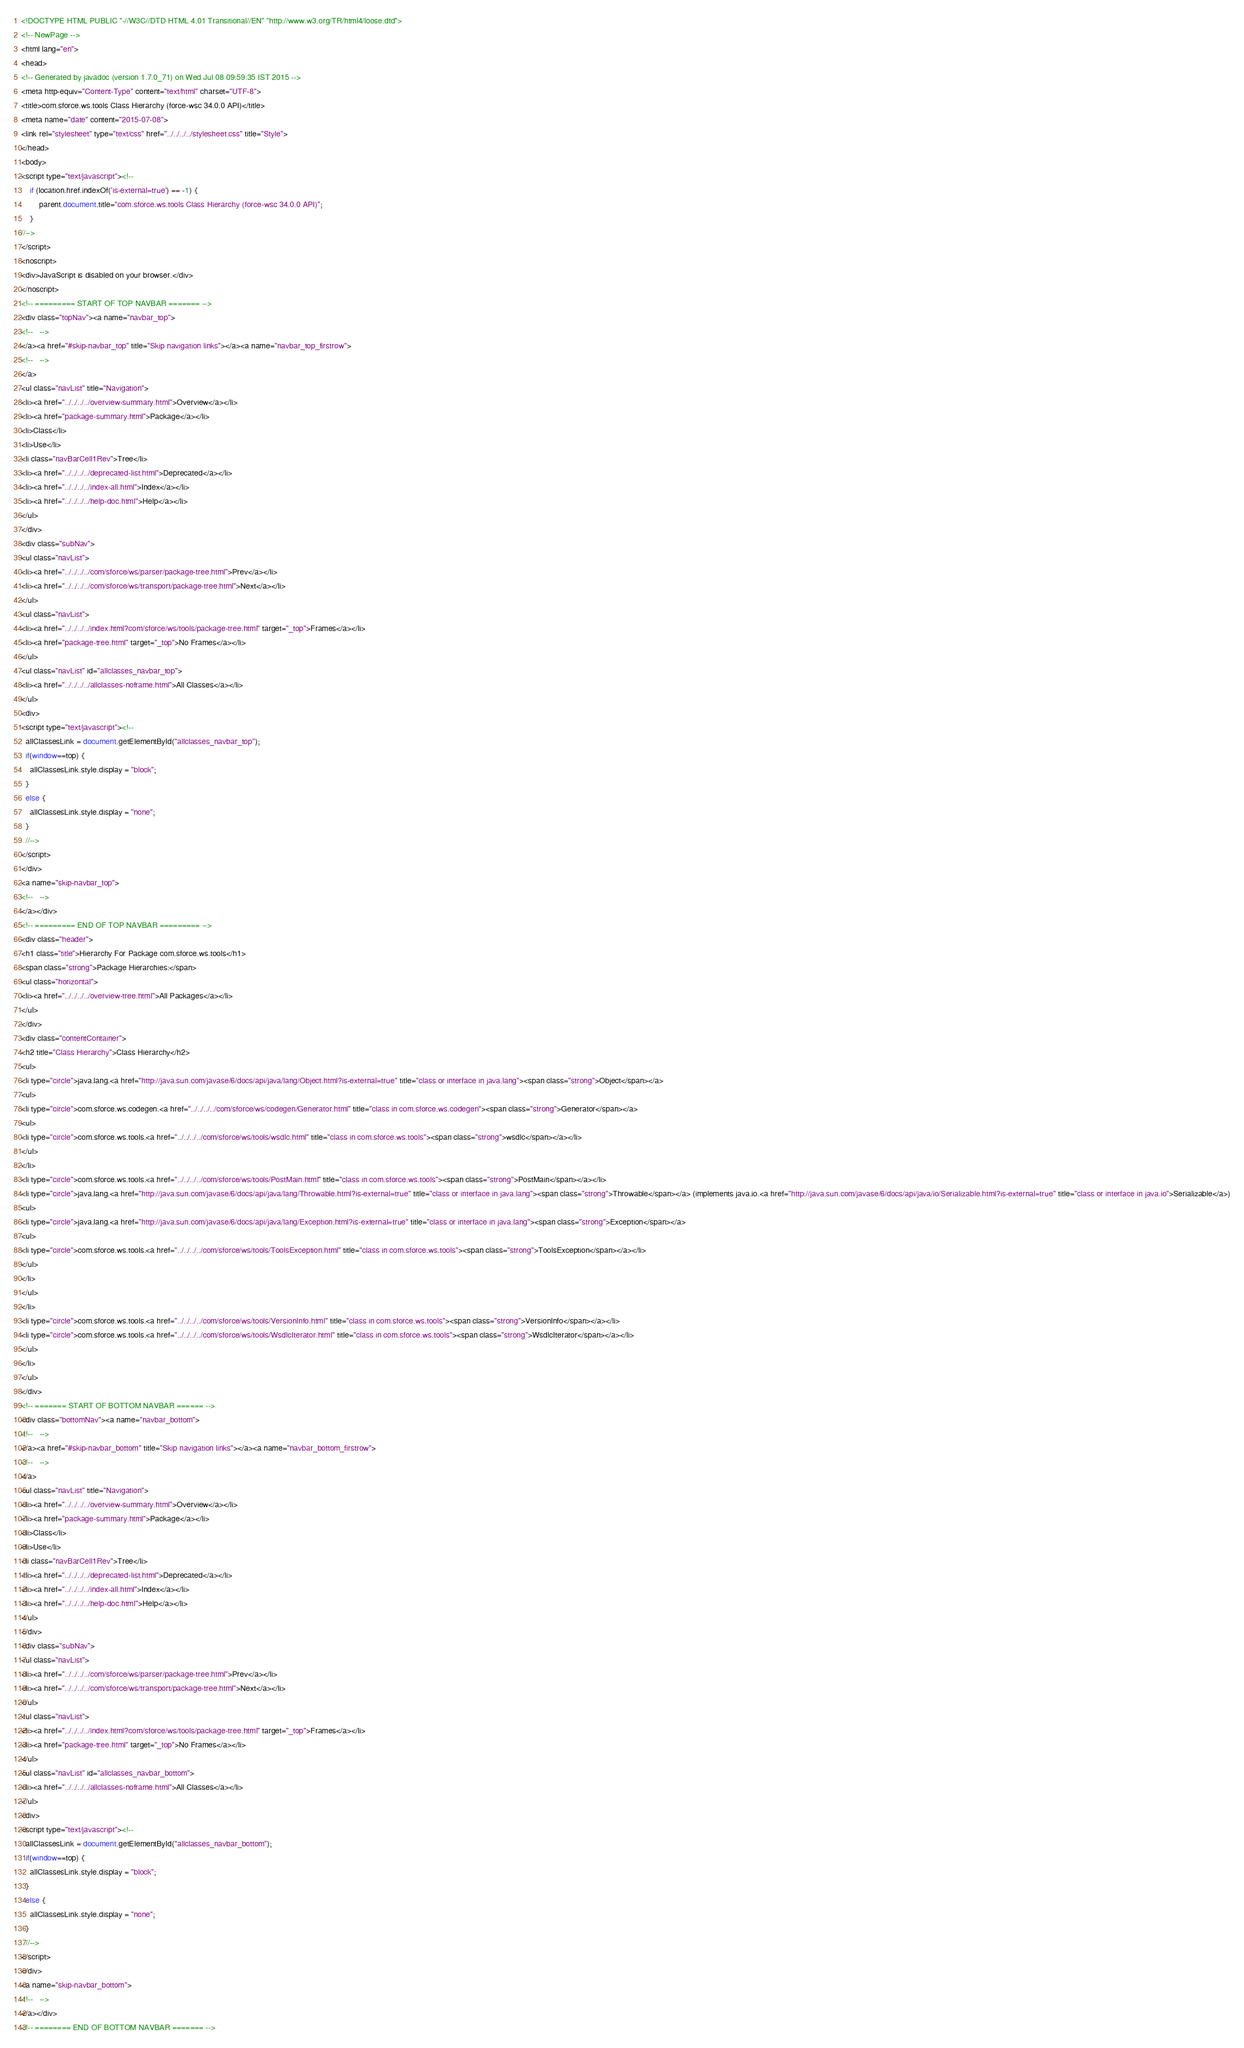<code> <loc_0><loc_0><loc_500><loc_500><_HTML_><!DOCTYPE HTML PUBLIC "-//W3C//DTD HTML 4.01 Transitional//EN" "http://www.w3.org/TR/html4/loose.dtd">
<!-- NewPage -->
<html lang="en">
<head>
<!-- Generated by javadoc (version 1.7.0_71) on Wed Jul 08 09:59:35 IST 2015 -->
<meta http-equiv="Content-Type" content="text/html" charset="UTF-8">
<title>com.sforce.ws.tools Class Hierarchy (force-wsc 34.0.0 API)</title>
<meta name="date" content="2015-07-08">
<link rel="stylesheet" type="text/css" href="../../../../stylesheet.css" title="Style">
</head>
<body>
<script type="text/javascript"><!--
    if (location.href.indexOf('is-external=true') == -1) {
        parent.document.title="com.sforce.ws.tools Class Hierarchy (force-wsc 34.0.0 API)";
    }
//-->
</script>
<noscript>
<div>JavaScript is disabled on your browser.</div>
</noscript>
<!-- ========= START OF TOP NAVBAR ======= -->
<div class="topNav"><a name="navbar_top">
<!--   -->
</a><a href="#skip-navbar_top" title="Skip navigation links"></a><a name="navbar_top_firstrow">
<!--   -->
</a>
<ul class="navList" title="Navigation">
<li><a href="../../../../overview-summary.html">Overview</a></li>
<li><a href="package-summary.html">Package</a></li>
<li>Class</li>
<li>Use</li>
<li class="navBarCell1Rev">Tree</li>
<li><a href="../../../../deprecated-list.html">Deprecated</a></li>
<li><a href="../../../../index-all.html">Index</a></li>
<li><a href="../../../../help-doc.html">Help</a></li>
</ul>
</div>
<div class="subNav">
<ul class="navList">
<li><a href="../../../../com/sforce/ws/parser/package-tree.html">Prev</a></li>
<li><a href="../../../../com/sforce/ws/transport/package-tree.html">Next</a></li>
</ul>
<ul class="navList">
<li><a href="../../../../index.html?com/sforce/ws/tools/package-tree.html" target="_top">Frames</a></li>
<li><a href="package-tree.html" target="_top">No Frames</a></li>
</ul>
<ul class="navList" id="allclasses_navbar_top">
<li><a href="../../../../allclasses-noframe.html">All Classes</a></li>
</ul>
<div>
<script type="text/javascript"><!--
  allClassesLink = document.getElementById("allclasses_navbar_top");
  if(window==top) {
    allClassesLink.style.display = "block";
  }
  else {
    allClassesLink.style.display = "none";
  }
  //-->
</script>
</div>
<a name="skip-navbar_top">
<!--   -->
</a></div>
<!-- ========= END OF TOP NAVBAR ========= -->
<div class="header">
<h1 class="title">Hierarchy For Package com.sforce.ws.tools</h1>
<span class="strong">Package Hierarchies:</span>
<ul class="horizontal">
<li><a href="../../../../overview-tree.html">All Packages</a></li>
</ul>
</div>
<div class="contentContainer">
<h2 title="Class Hierarchy">Class Hierarchy</h2>
<ul>
<li type="circle">java.lang.<a href="http://java.sun.com/javase/6/docs/api/java/lang/Object.html?is-external=true" title="class or interface in java.lang"><span class="strong">Object</span></a>
<ul>
<li type="circle">com.sforce.ws.codegen.<a href="../../../../com/sforce/ws/codegen/Generator.html" title="class in com.sforce.ws.codegen"><span class="strong">Generator</span></a>
<ul>
<li type="circle">com.sforce.ws.tools.<a href="../../../../com/sforce/ws/tools/wsdlc.html" title="class in com.sforce.ws.tools"><span class="strong">wsdlc</span></a></li>
</ul>
</li>
<li type="circle">com.sforce.ws.tools.<a href="../../../../com/sforce/ws/tools/PostMain.html" title="class in com.sforce.ws.tools"><span class="strong">PostMain</span></a></li>
<li type="circle">java.lang.<a href="http://java.sun.com/javase/6/docs/api/java/lang/Throwable.html?is-external=true" title="class or interface in java.lang"><span class="strong">Throwable</span></a> (implements java.io.<a href="http://java.sun.com/javase/6/docs/api/java/io/Serializable.html?is-external=true" title="class or interface in java.io">Serializable</a>)
<ul>
<li type="circle">java.lang.<a href="http://java.sun.com/javase/6/docs/api/java/lang/Exception.html?is-external=true" title="class or interface in java.lang"><span class="strong">Exception</span></a>
<ul>
<li type="circle">com.sforce.ws.tools.<a href="../../../../com/sforce/ws/tools/ToolsException.html" title="class in com.sforce.ws.tools"><span class="strong">ToolsException</span></a></li>
</ul>
</li>
</ul>
</li>
<li type="circle">com.sforce.ws.tools.<a href="../../../../com/sforce/ws/tools/VersionInfo.html" title="class in com.sforce.ws.tools"><span class="strong">VersionInfo</span></a></li>
<li type="circle">com.sforce.ws.tools.<a href="../../../../com/sforce/ws/tools/WsdlcIterator.html" title="class in com.sforce.ws.tools"><span class="strong">WsdlcIterator</span></a></li>
</ul>
</li>
</ul>
</div>
<!-- ======= START OF BOTTOM NAVBAR ====== -->
<div class="bottomNav"><a name="navbar_bottom">
<!--   -->
</a><a href="#skip-navbar_bottom" title="Skip navigation links"></a><a name="navbar_bottom_firstrow">
<!--   -->
</a>
<ul class="navList" title="Navigation">
<li><a href="../../../../overview-summary.html">Overview</a></li>
<li><a href="package-summary.html">Package</a></li>
<li>Class</li>
<li>Use</li>
<li class="navBarCell1Rev">Tree</li>
<li><a href="../../../../deprecated-list.html">Deprecated</a></li>
<li><a href="../../../../index-all.html">Index</a></li>
<li><a href="../../../../help-doc.html">Help</a></li>
</ul>
</div>
<div class="subNav">
<ul class="navList">
<li><a href="../../../../com/sforce/ws/parser/package-tree.html">Prev</a></li>
<li><a href="../../../../com/sforce/ws/transport/package-tree.html">Next</a></li>
</ul>
<ul class="navList">
<li><a href="../../../../index.html?com/sforce/ws/tools/package-tree.html" target="_top">Frames</a></li>
<li><a href="package-tree.html" target="_top">No Frames</a></li>
</ul>
<ul class="navList" id="allclasses_navbar_bottom">
<li><a href="../../../../allclasses-noframe.html">All Classes</a></li>
</ul>
<div>
<script type="text/javascript"><!--
  allClassesLink = document.getElementById("allclasses_navbar_bottom");
  if(window==top) {
    allClassesLink.style.display = "block";
  }
  else {
    allClassesLink.style.display = "none";
  }
  //-->
</script>
</div>
<a name="skip-navbar_bottom">
<!--   -->
</a></div>
<!-- ======== END OF BOTTOM NAVBAR ======= --></code> 